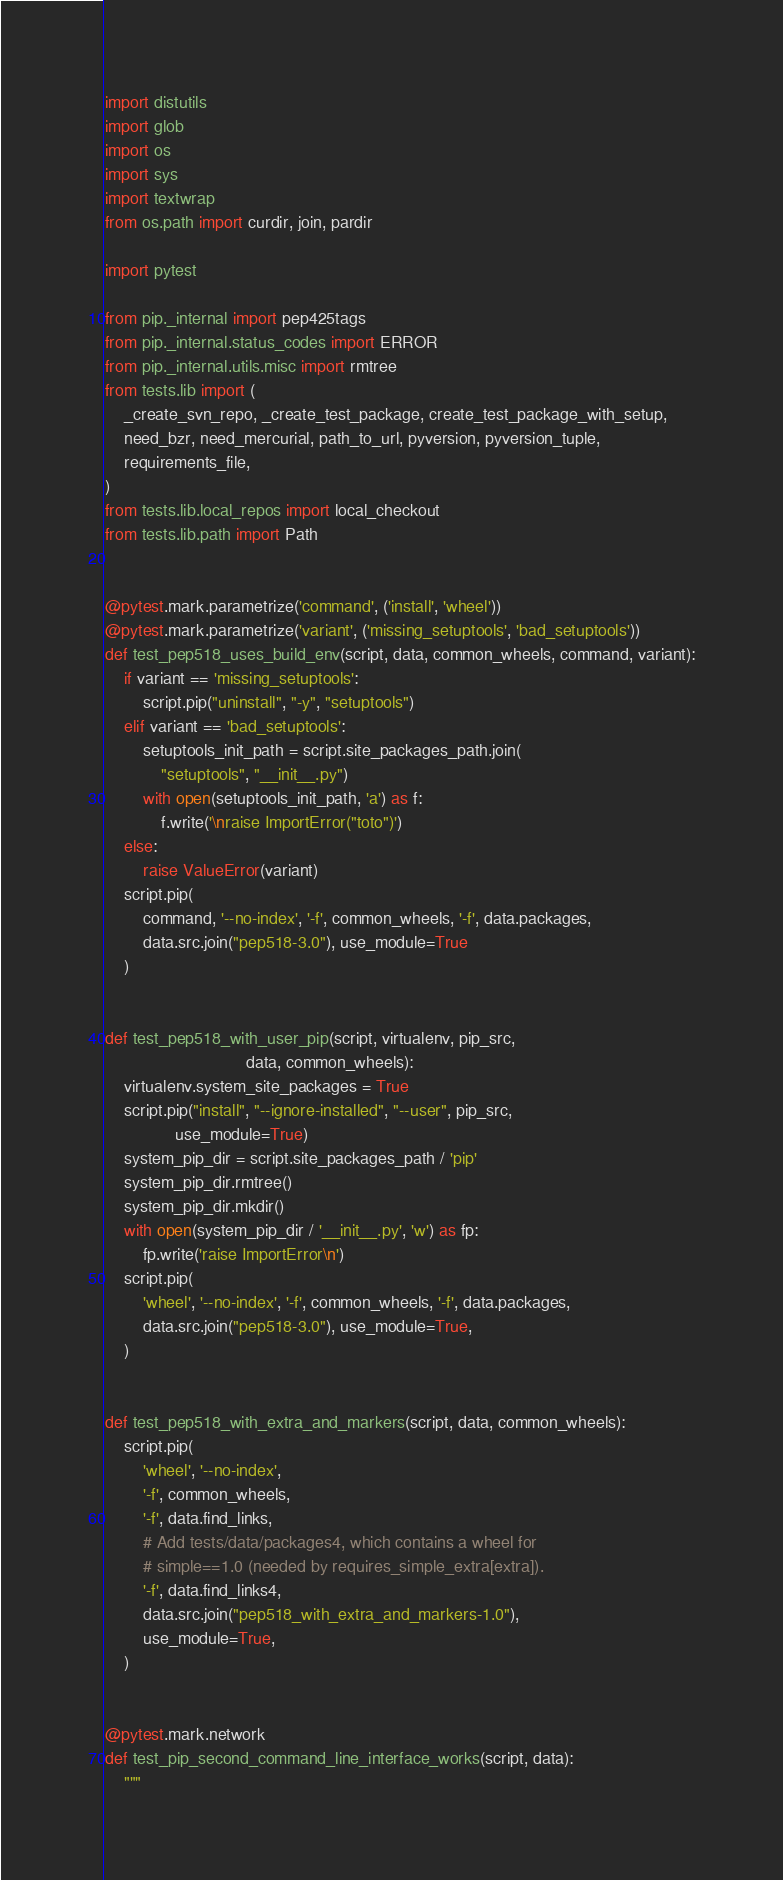<code> <loc_0><loc_0><loc_500><loc_500><_Python_>import distutils
import glob
import os
import sys
import textwrap
from os.path import curdir, join, pardir

import pytest

from pip._internal import pep425tags
from pip._internal.status_codes import ERROR
from pip._internal.utils.misc import rmtree
from tests.lib import (
    _create_svn_repo, _create_test_package, create_test_package_with_setup,
    need_bzr, need_mercurial, path_to_url, pyversion, pyversion_tuple,
    requirements_file,
)
from tests.lib.local_repos import local_checkout
from tests.lib.path import Path


@pytest.mark.parametrize('command', ('install', 'wheel'))
@pytest.mark.parametrize('variant', ('missing_setuptools', 'bad_setuptools'))
def test_pep518_uses_build_env(script, data, common_wheels, command, variant):
    if variant == 'missing_setuptools':
        script.pip("uninstall", "-y", "setuptools")
    elif variant == 'bad_setuptools':
        setuptools_init_path = script.site_packages_path.join(
            "setuptools", "__init__.py")
        with open(setuptools_init_path, 'a') as f:
            f.write('\nraise ImportError("toto")')
    else:
        raise ValueError(variant)
    script.pip(
        command, '--no-index', '-f', common_wheels, '-f', data.packages,
        data.src.join("pep518-3.0"), use_module=True
    )


def test_pep518_with_user_pip(script, virtualenv, pip_src,
                              data, common_wheels):
    virtualenv.system_site_packages = True
    script.pip("install", "--ignore-installed", "--user", pip_src,
               use_module=True)
    system_pip_dir = script.site_packages_path / 'pip'
    system_pip_dir.rmtree()
    system_pip_dir.mkdir()
    with open(system_pip_dir / '__init__.py', 'w') as fp:
        fp.write('raise ImportError\n')
    script.pip(
        'wheel', '--no-index', '-f', common_wheels, '-f', data.packages,
        data.src.join("pep518-3.0"), use_module=True,
    )


def test_pep518_with_extra_and_markers(script, data, common_wheels):
    script.pip(
        'wheel', '--no-index',
        '-f', common_wheels,
        '-f', data.find_links,
        # Add tests/data/packages4, which contains a wheel for
        # simple==1.0 (needed by requires_simple_extra[extra]).
        '-f', data.find_links4,
        data.src.join("pep518_with_extra_and_markers-1.0"),
        use_module=True,
    )


@pytest.mark.network
def test_pip_second_command_line_interface_works(script, data):
    """</code> 